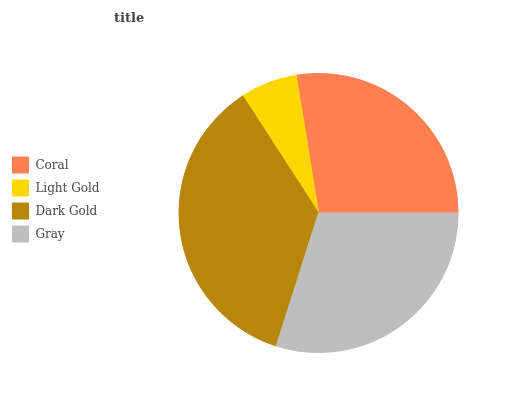Is Light Gold the minimum?
Answer yes or no. Yes. Is Dark Gold the maximum?
Answer yes or no. Yes. Is Dark Gold the minimum?
Answer yes or no. No. Is Light Gold the maximum?
Answer yes or no. No. Is Dark Gold greater than Light Gold?
Answer yes or no. Yes. Is Light Gold less than Dark Gold?
Answer yes or no. Yes. Is Light Gold greater than Dark Gold?
Answer yes or no. No. Is Dark Gold less than Light Gold?
Answer yes or no. No. Is Gray the high median?
Answer yes or no. Yes. Is Coral the low median?
Answer yes or no. Yes. Is Coral the high median?
Answer yes or no. No. Is Dark Gold the low median?
Answer yes or no. No. 